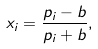<formula> <loc_0><loc_0><loc_500><loc_500>x _ { i } = { \frac { p _ { i } - b } { p _ { i } + b } } ,</formula> 